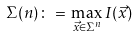<formula> <loc_0><loc_0><loc_500><loc_500>\Sigma ( n ) \, \colon = \, \max _ { \vec { x } \in \Sigma ^ { n } } I ( \vec { x } )</formula> 